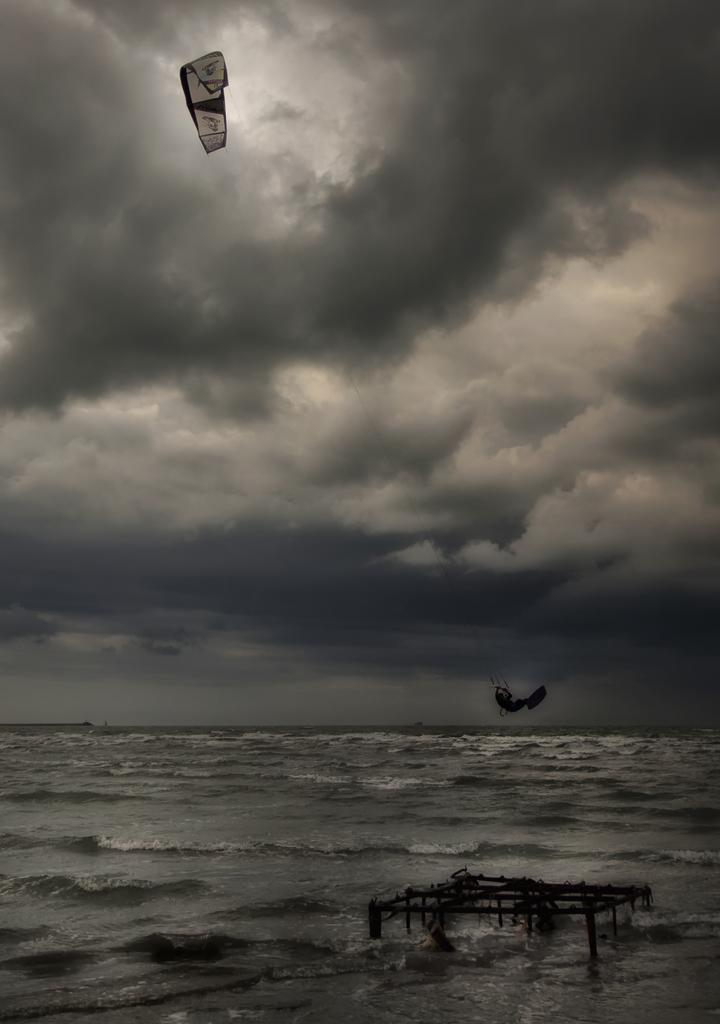What is the color scheme of the image? The image is black and white. What is present in the water in the image? There is a stand in the water. What object can be seen in the sky? There is a parachute in the image. What can be seen in the background of the image? The sky with clouds is visible in the background. Can you tell me what type of guitar is being played by the spy in the image? There is no spy or guitar present in the image. What color is the gold object in the image? There is no gold object present in the image. 